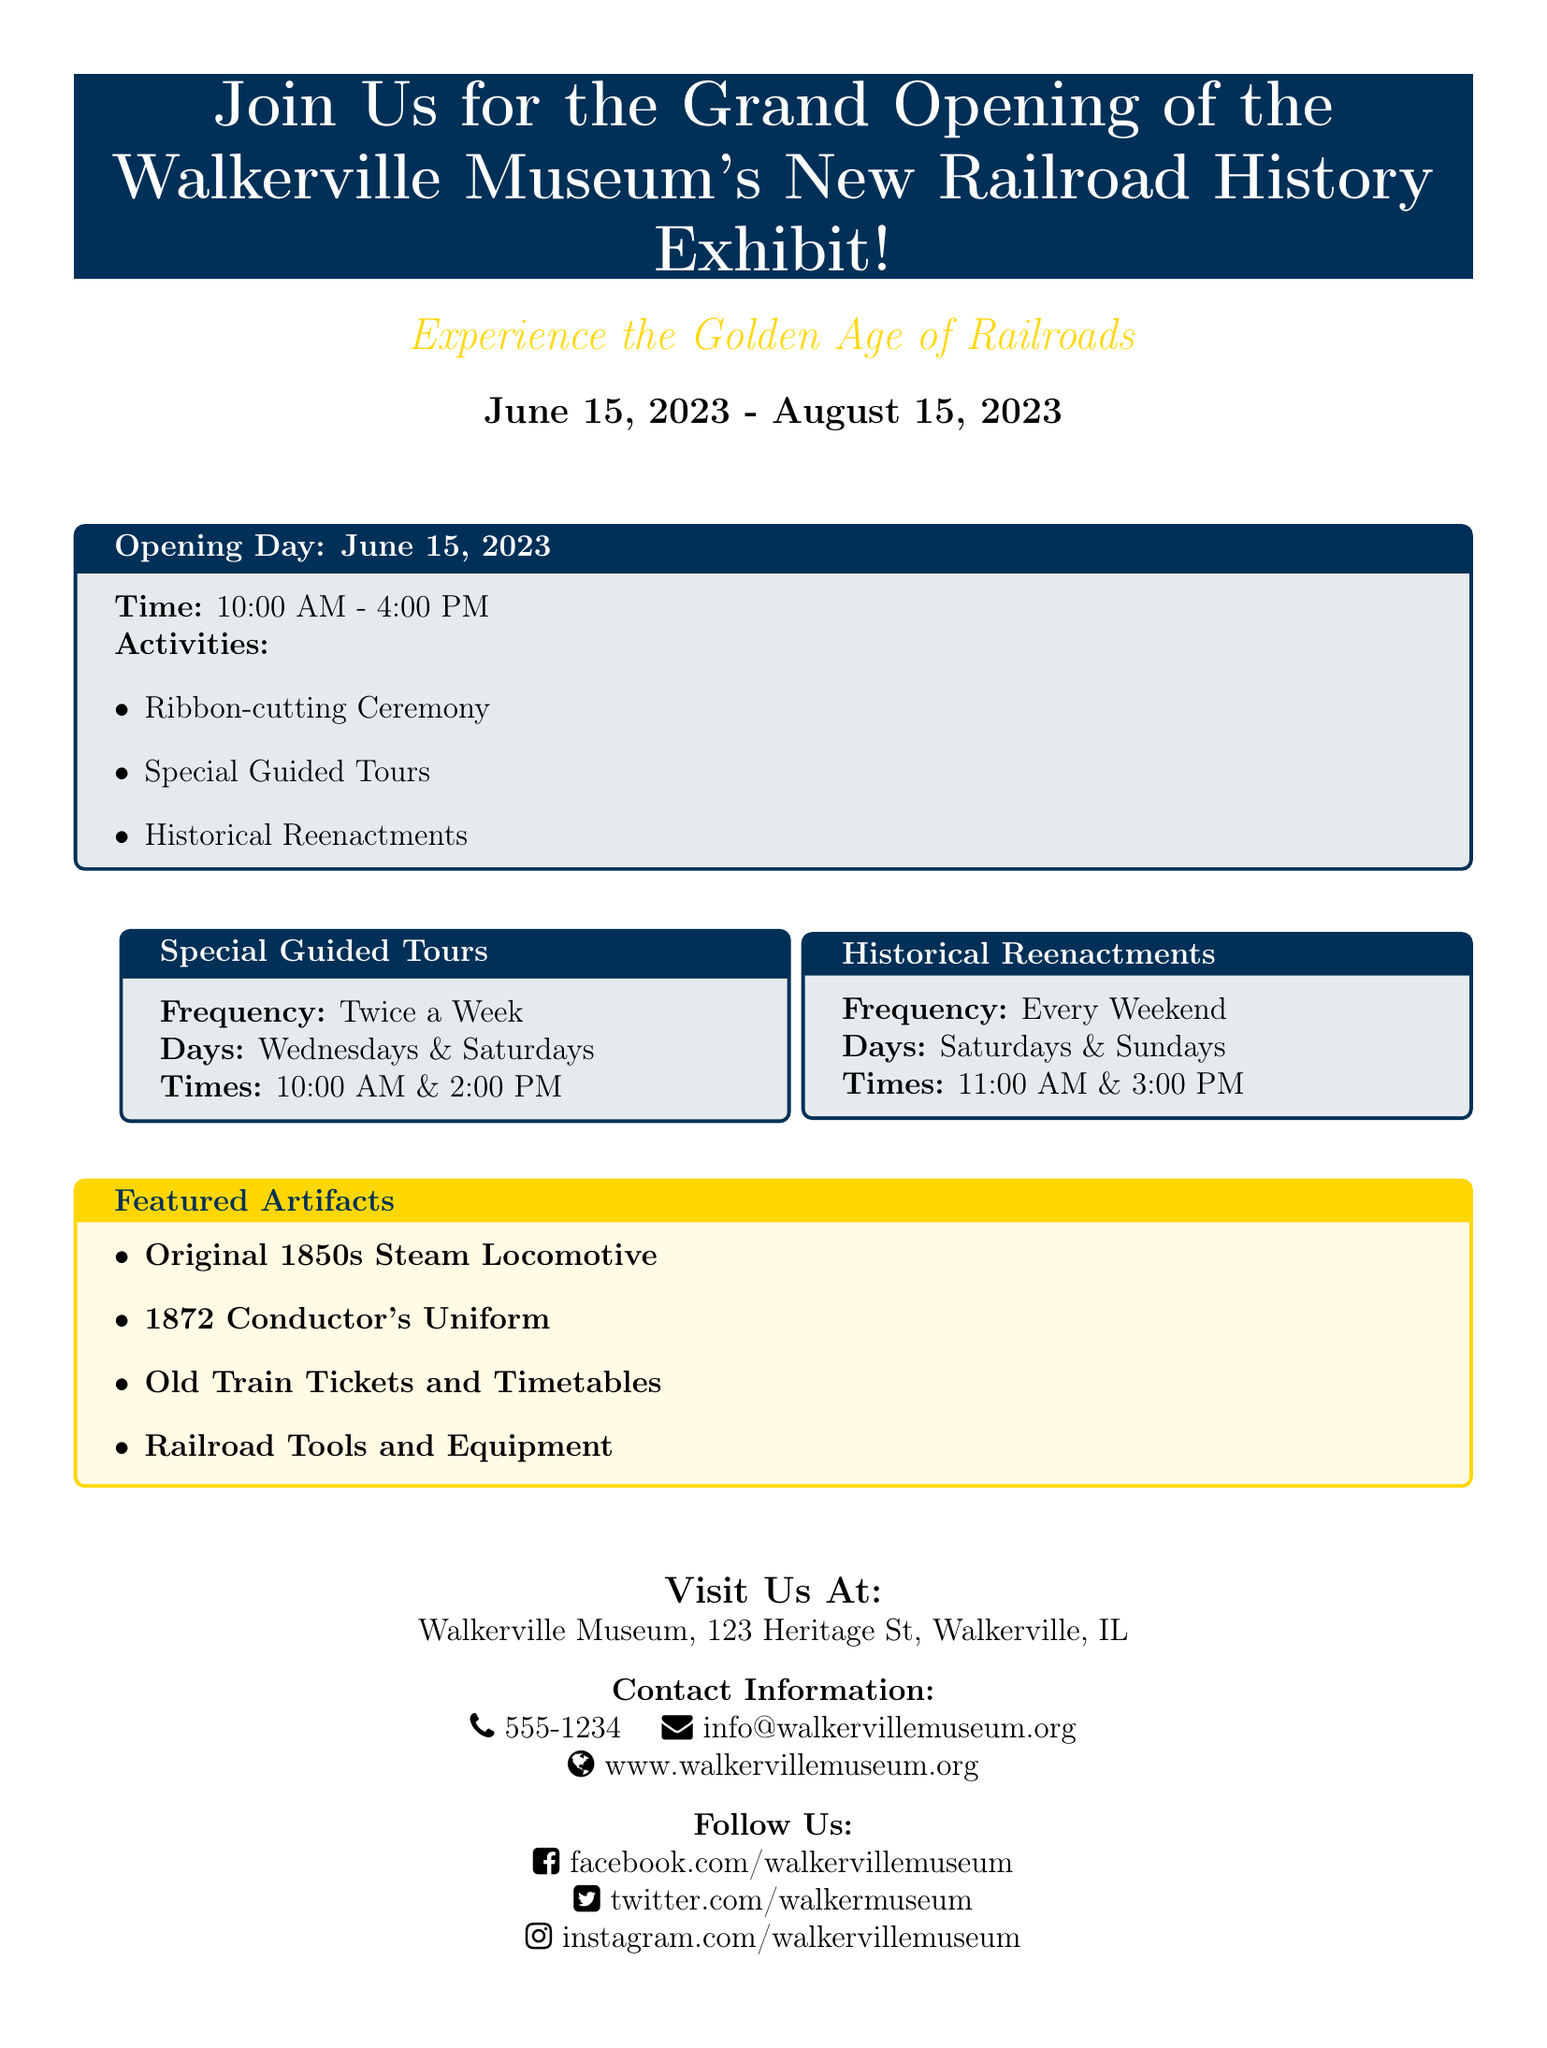What is the title of the exhibit? The title of the exhibit is mentioned prominently at the beginning of the document, highlighting the event's focus.
Answer: Grand Opening of the Walkerville Museum's New Railroad History Exhibit When does the exhibit open? The opening date is clearly stated in the document, providing essential timing information.
Answer: June 15, 2023 How long will the exhibit run? The duration of the exhibit is specified in the opening section, which is important for visitors to plan their visit.
Answer: August 15, 2023 What time does the opening day event start? The start time for the opening day activities is outlined in the opening day section.
Answer: 10:00 AM On which days are the special guided tours offered? The days for special guided tours are listed, providing critical details for planning visits.
Answer: Wednesdays & Saturdays How often do historical reenactments take place? The frequency of the historical reenactments is mentioned in the relevant section, indicating how often visitors can experience this activity.
Answer: Every Weekend What is one of the featured artifacts? The document lists featured artifacts, which is an essential aspect of the exhibit that may attract interest.
Answer: Original 1850s Steam Locomotive Where is the Walkerville Museum located? The location is provided in detail, giving essential information for visitors.
Answer: 123 Heritage St, Walkerville, IL What is the contact phone number for the museum? The contact information includes a phone number, crucial for visitor inquiries.
Answer: 555-1234 Which social media platform is mentioned for following the museum? The document highlights various social media links, useful for audience engagement.
Answer: Facebook 